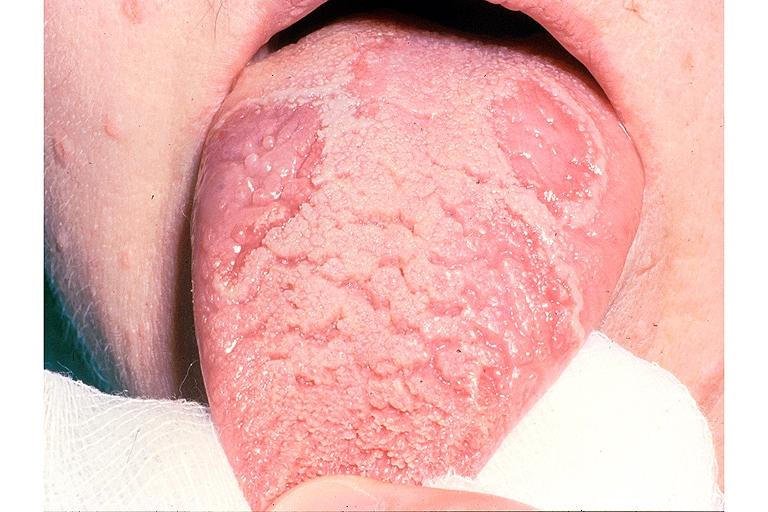where is this?
Answer the question using a single word or phrase. Oral 